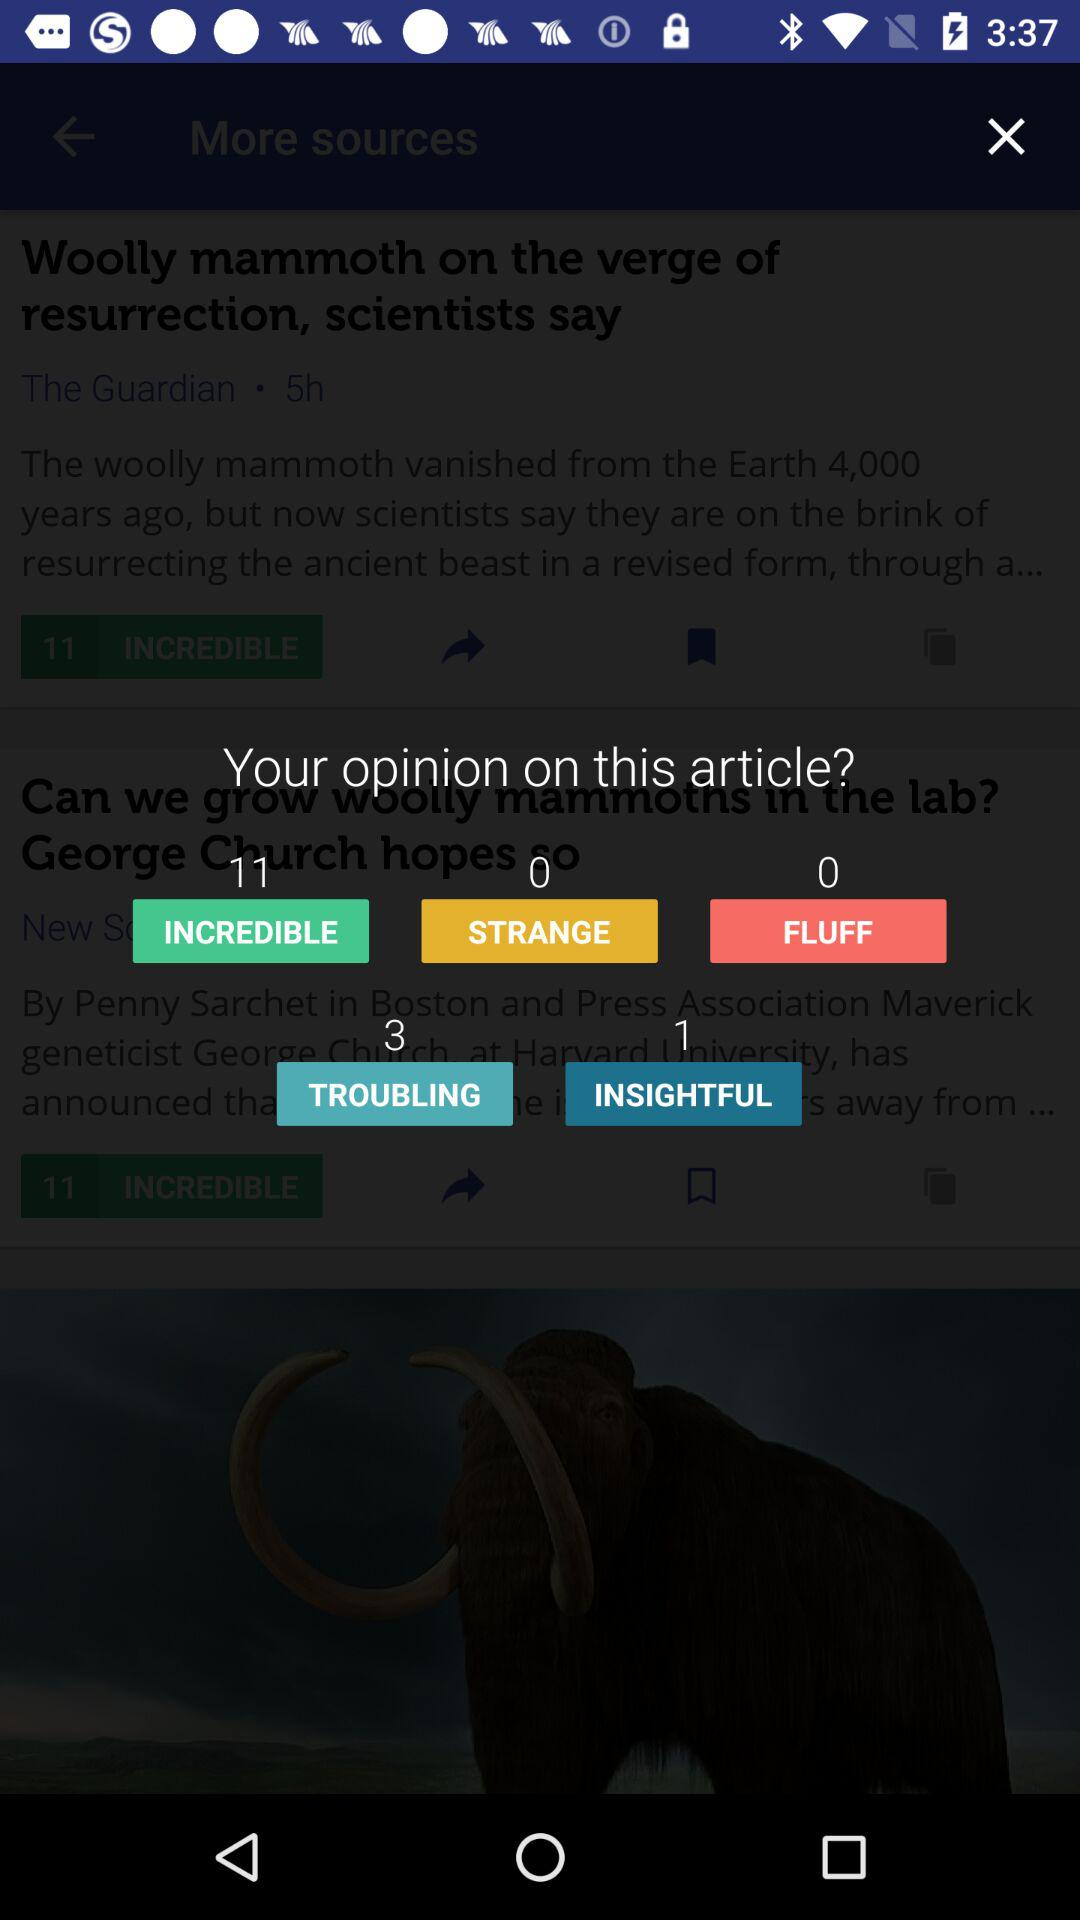What is the total number of people who thought the article was "INSIGHTFUL"? The total number of people who thought the article was "INSIGHTFUL" is 1. 